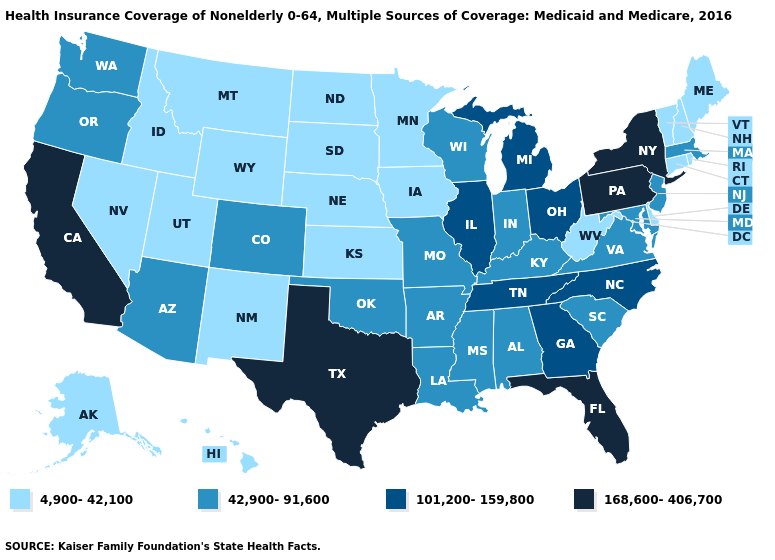Does Wyoming have a higher value than Oregon?
Answer briefly. No. Does Colorado have a lower value than Pennsylvania?
Quick response, please. Yes. Name the states that have a value in the range 101,200-159,800?
Be succinct. Georgia, Illinois, Michigan, North Carolina, Ohio, Tennessee. Which states have the highest value in the USA?
Short answer required. California, Florida, New York, Pennsylvania, Texas. Name the states that have a value in the range 168,600-406,700?
Short answer required. California, Florida, New York, Pennsylvania, Texas. How many symbols are there in the legend?
Quick response, please. 4. Does Maine have a lower value than Virginia?
Give a very brief answer. Yes. Which states hav the highest value in the MidWest?
Answer briefly. Illinois, Michigan, Ohio. Among the states that border Wisconsin , does Michigan have the lowest value?
Concise answer only. No. What is the highest value in the MidWest ?
Answer briefly. 101,200-159,800. Does Ohio have the highest value in the MidWest?
Concise answer only. Yes. What is the highest value in states that border Texas?
Give a very brief answer. 42,900-91,600. Among the states that border Arizona , does Colorado have the highest value?
Give a very brief answer. No. What is the highest value in the MidWest ?
Short answer required. 101,200-159,800. What is the value of Pennsylvania?
Keep it brief. 168,600-406,700. 